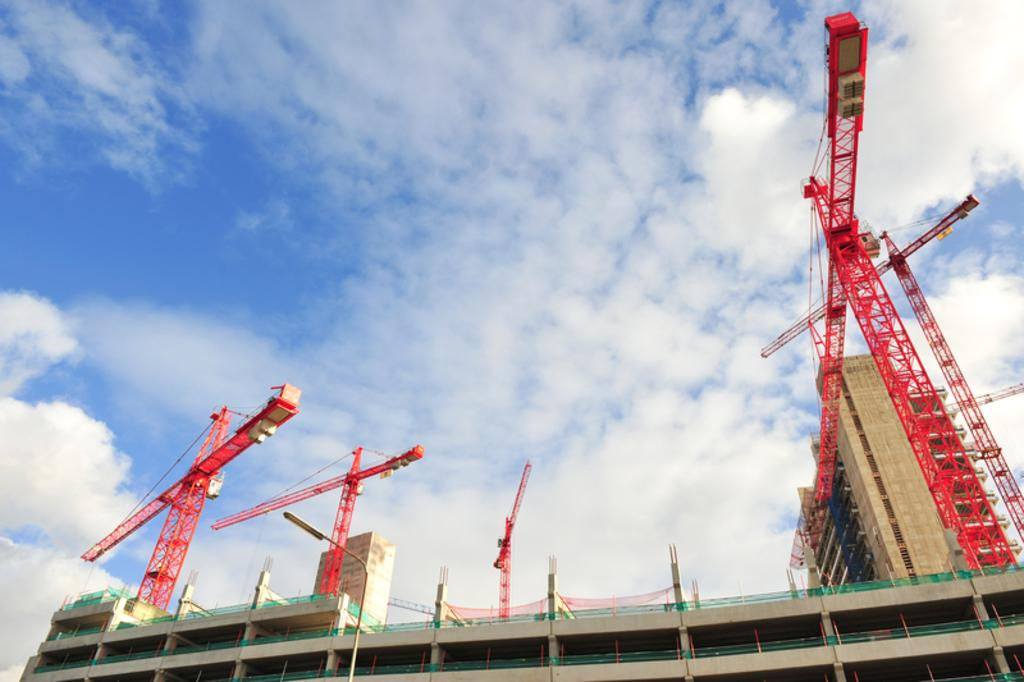What is the main subject of the image? The main subject of the image is a building. What is the current state of the building? The building is under construction. Are there any additional structures on top of the building? Yes, there are stands on top of the building. How would you describe the weather based on the image? The sky is cloudy in the image. What type of amusement can be seen on the plate in the image? There is no plate or amusement present in the image; it features a building under construction with stands on top. 